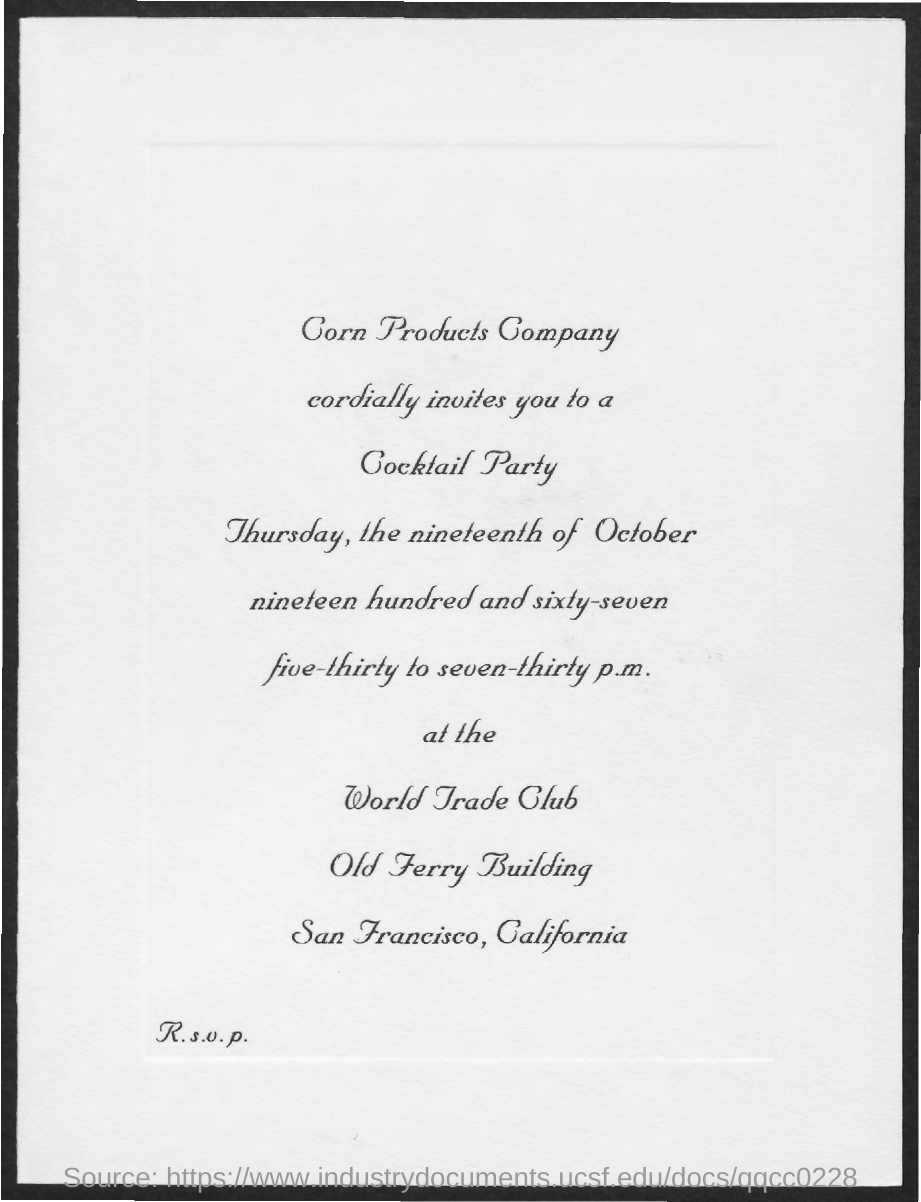Give some essential details in this illustration. The purpose of the invitation is to attend a cocktail party. 